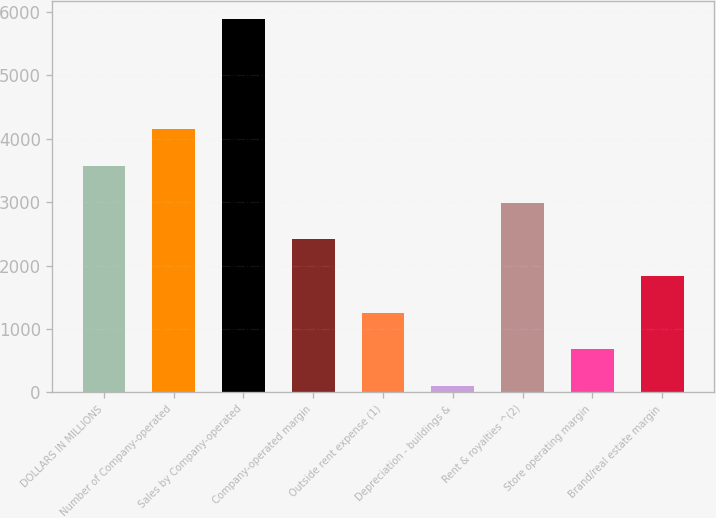<chart> <loc_0><loc_0><loc_500><loc_500><bar_chart><fcel>DOLLARS IN MILLIONS<fcel>Number of Company-operated<fcel>Sales by Company-operated<fcel>Company-operated margin<fcel>Outside rent expense (1)<fcel>Depreciation - buildings &<fcel>Rent & royalties ^(2)<fcel>Store operating margin<fcel>Brand/real estate margin<nl><fcel>3570.2<fcel>4148.9<fcel>5885<fcel>2412.8<fcel>1255.4<fcel>98<fcel>2991.5<fcel>676.7<fcel>1834.1<nl></chart> 